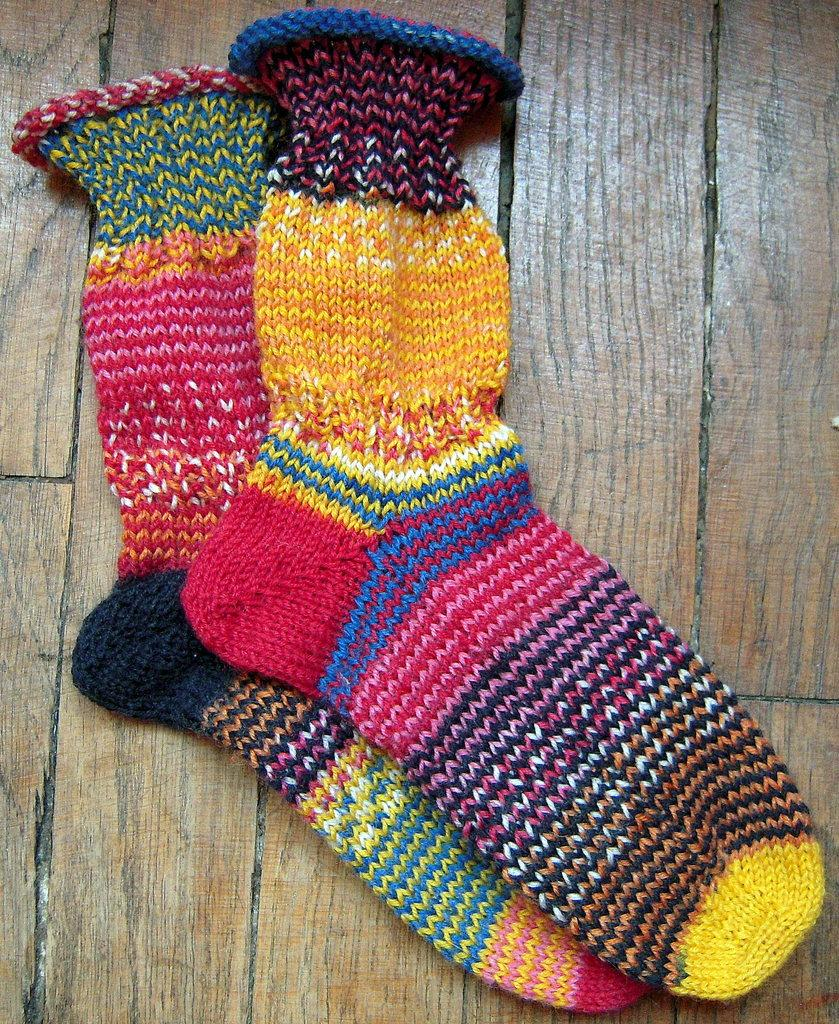What type of clothing item is present in the image? There are socks in the image. On what surface are the socks placed? The socks are on a wood surface. What type of fuel is being used to power the tramp in the image? There is no tramp present in the image, so the type of fuel cannot be determined. 